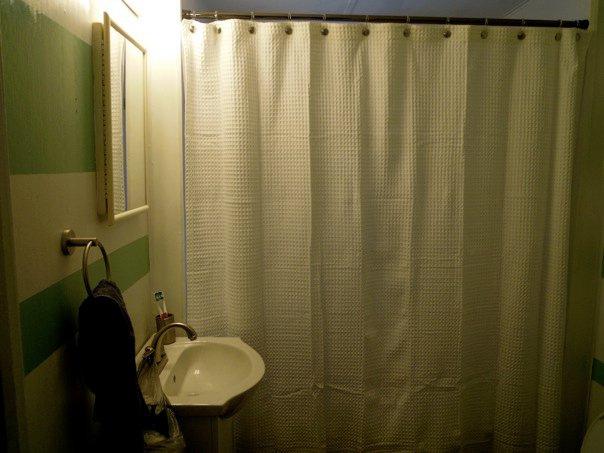Was the shower curtain ironed?
Short answer required. No. What is on the sink?
Give a very brief answer. Toothbrushes. What color are the stripes on the wall?
Concise answer only. Green. 